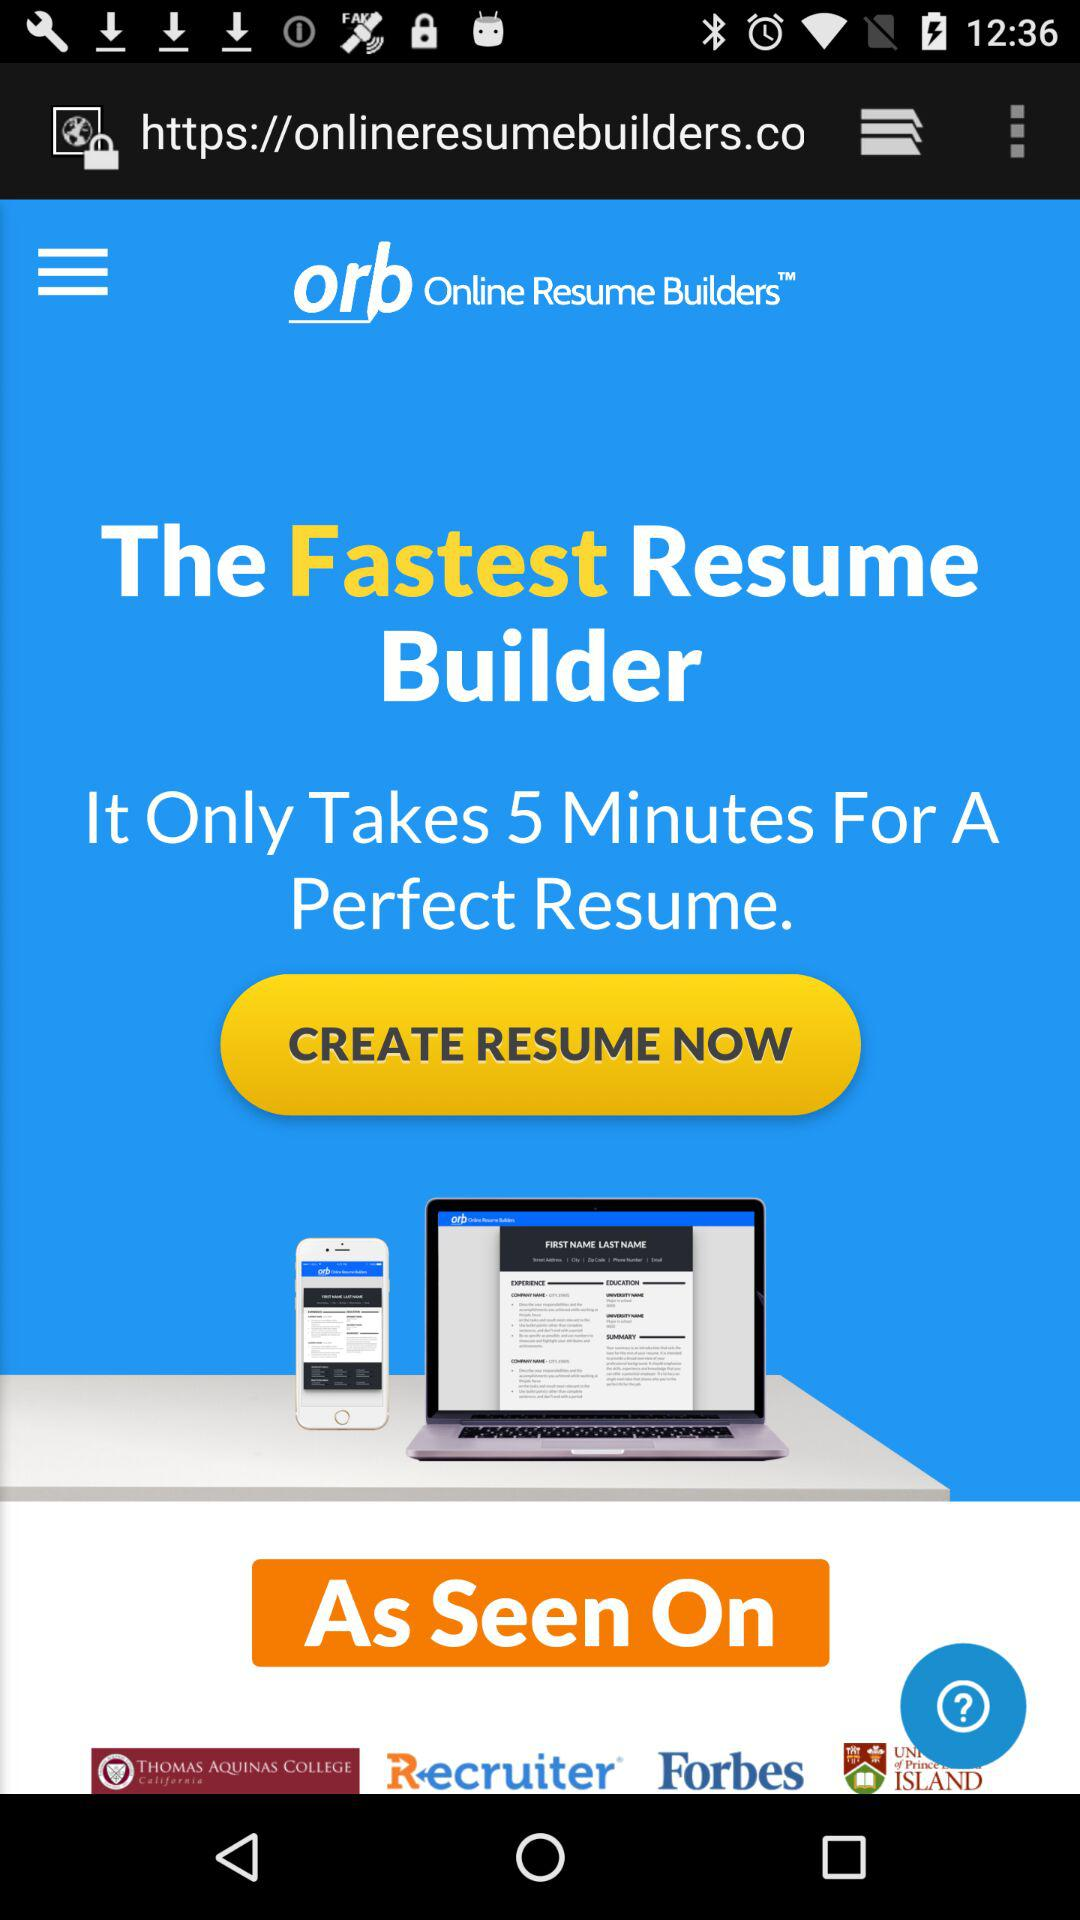How long will it take to build a perfect resume? It will take 5 minutes to build a perfect resume. 